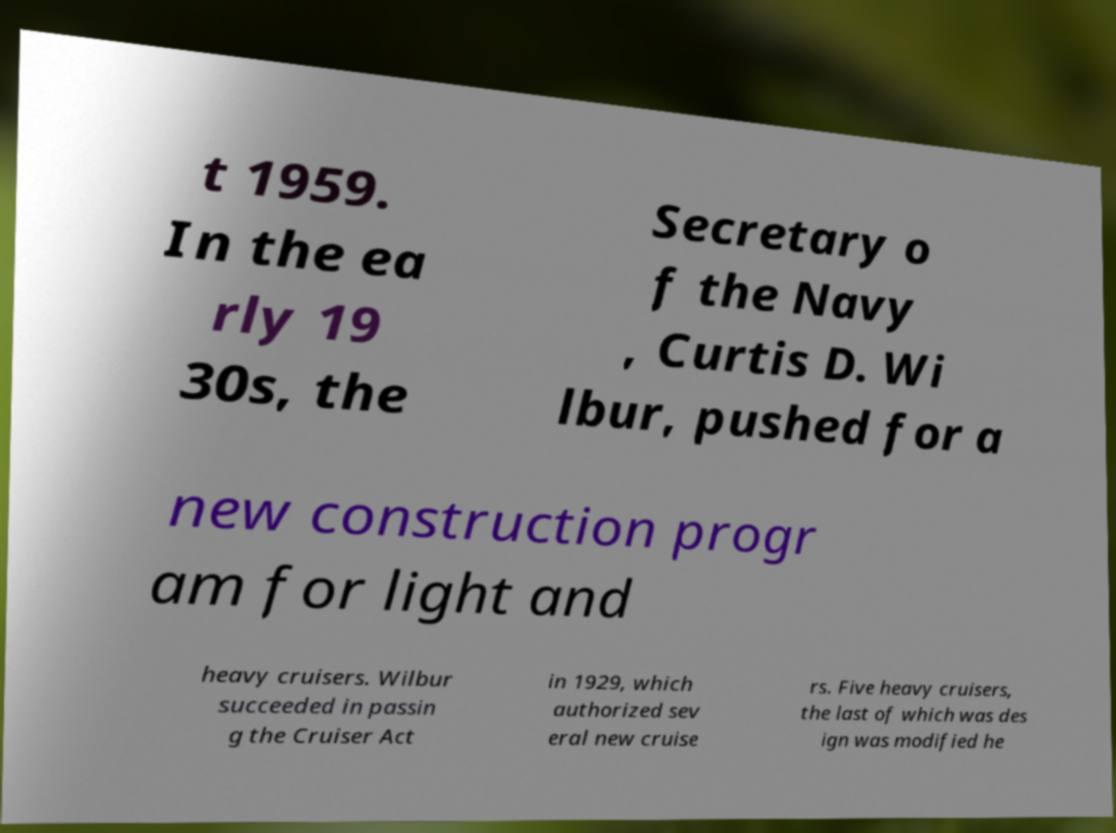Can you accurately transcribe the text from the provided image for me? t 1959. In the ea rly 19 30s, the Secretary o f the Navy , Curtis D. Wi lbur, pushed for a new construction progr am for light and heavy cruisers. Wilbur succeeded in passin g the Cruiser Act in 1929, which authorized sev eral new cruise rs. Five heavy cruisers, the last of which was des ign was modified he 